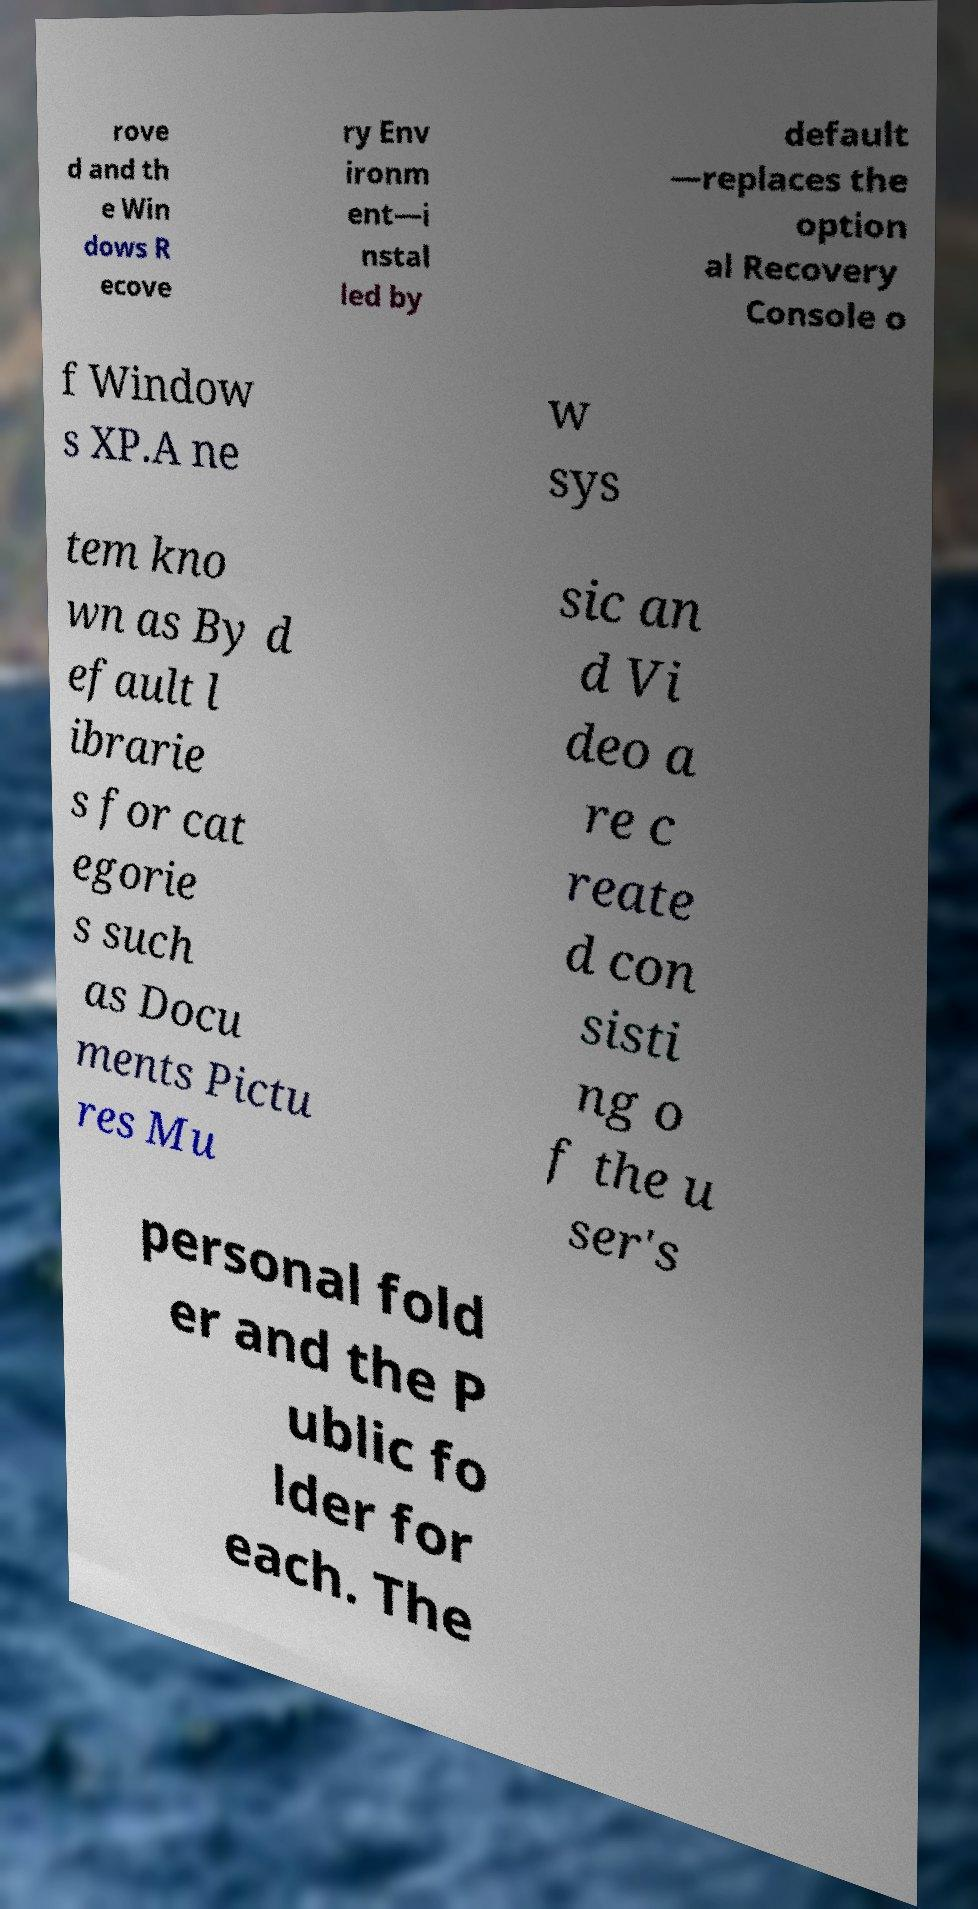Please read and relay the text visible in this image. What does it say? rove d and th e Win dows R ecove ry Env ironm ent—i nstal led by default —replaces the option al Recovery Console o f Window s XP.A ne w sys tem kno wn as By d efault l ibrarie s for cat egorie s such as Docu ments Pictu res Mu sic an d Vi deo a re c reate d con sisti ng o f the u ser's personal fold er and the P ublic fo lder for each. The 